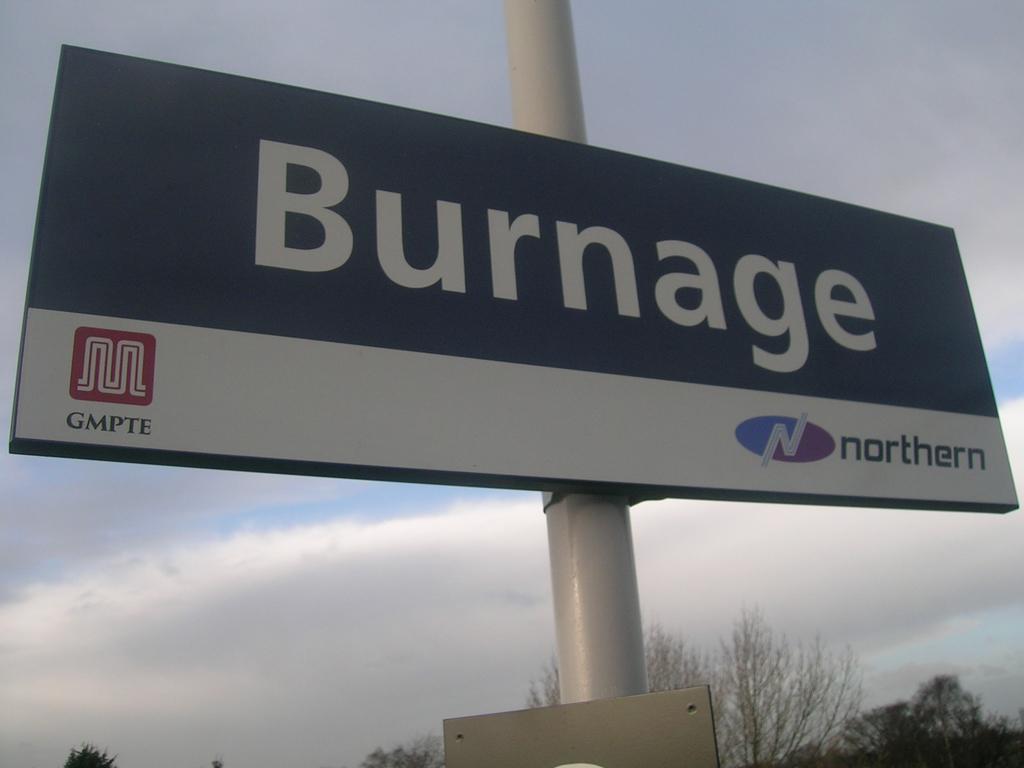What does it say under the red symbol?
Keep it short and to the point. Gmpte. Burnage gmpte northern?
Ensure brevity in your answer.  Yes. 